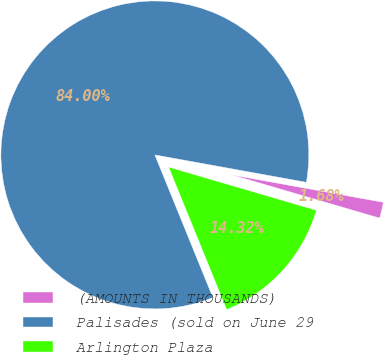Convert chart to OTSL. <chart><loc_0><loc_0><loc_500><loc_500><pie_chart><fcel>(AMOUNTS IN THOUSANDS)<fcel>Palisades (sold on June 29<fcel>Arlington Plaza<nl><fcel>1.68%<fcel>83.99%<fcel>14.32%<nl></chart> 